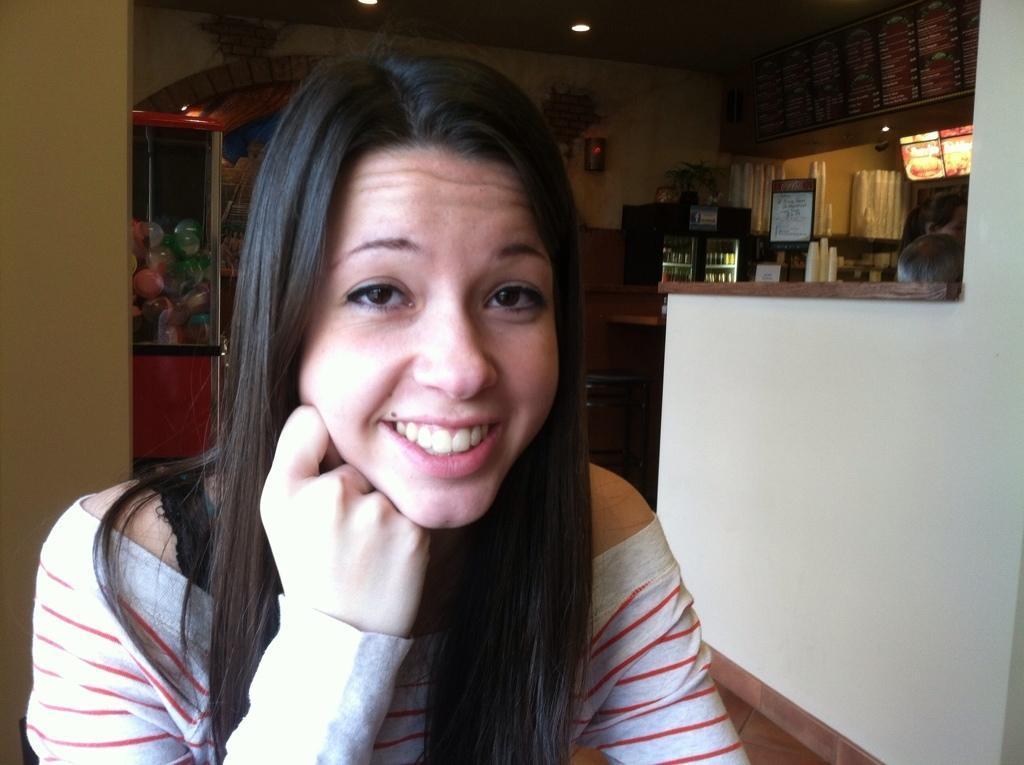Could you give a brief overview of what you see in this image? In this image we can see a lady smiling. In the back there is a box with balls. There is a wall with painting. Also there is another box. Inside that there are some items. And there are cups. Also there is a board with something written. On the ceiling there are lights. And we can see two persons. And there is a wall on the right side. 